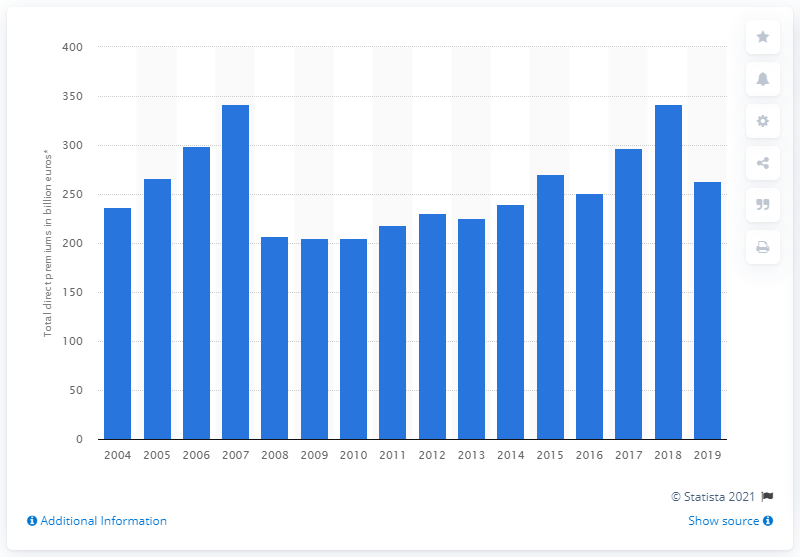Mention a couple of crucial points in this snapshot. In 2007, the amount of written premiums in the UK reached its peak. In 2008, the value of written premiums decreased sharply. According to data from 2007, the total amount of premiums written for the insurance industry in the UK was 341.61. In 2019, the amount of premiums was 263.59. 